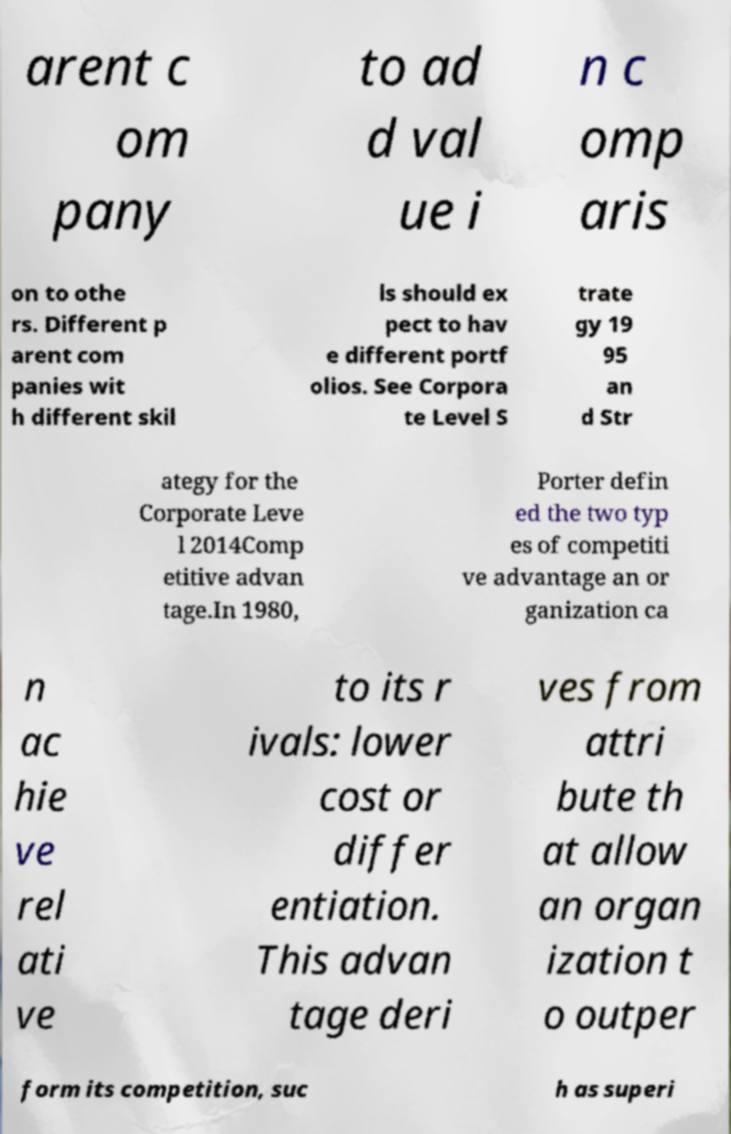What messages or text are displayed in this image? I need them in a readable, typed format. arent c om pany to ad d val ue i n c omp aris on to othe rs. Different p arent com panies wit h different skil ls should ex pect to hav e different portf olios. See Corpora te Level S trate gy 19 95 an d Str ategy for the Corporate Leve l 2014Comp etitive advan tage.In 1980, Porter defin ed the two typ es of competiti ve advantage an or ganization ca n ac hie ve rel ati ve to its r ivals: lower cost or differ entiation. This advan tage deri ves from attri bute th at allow an organ ization t o outper form its competition, suc h as superi 